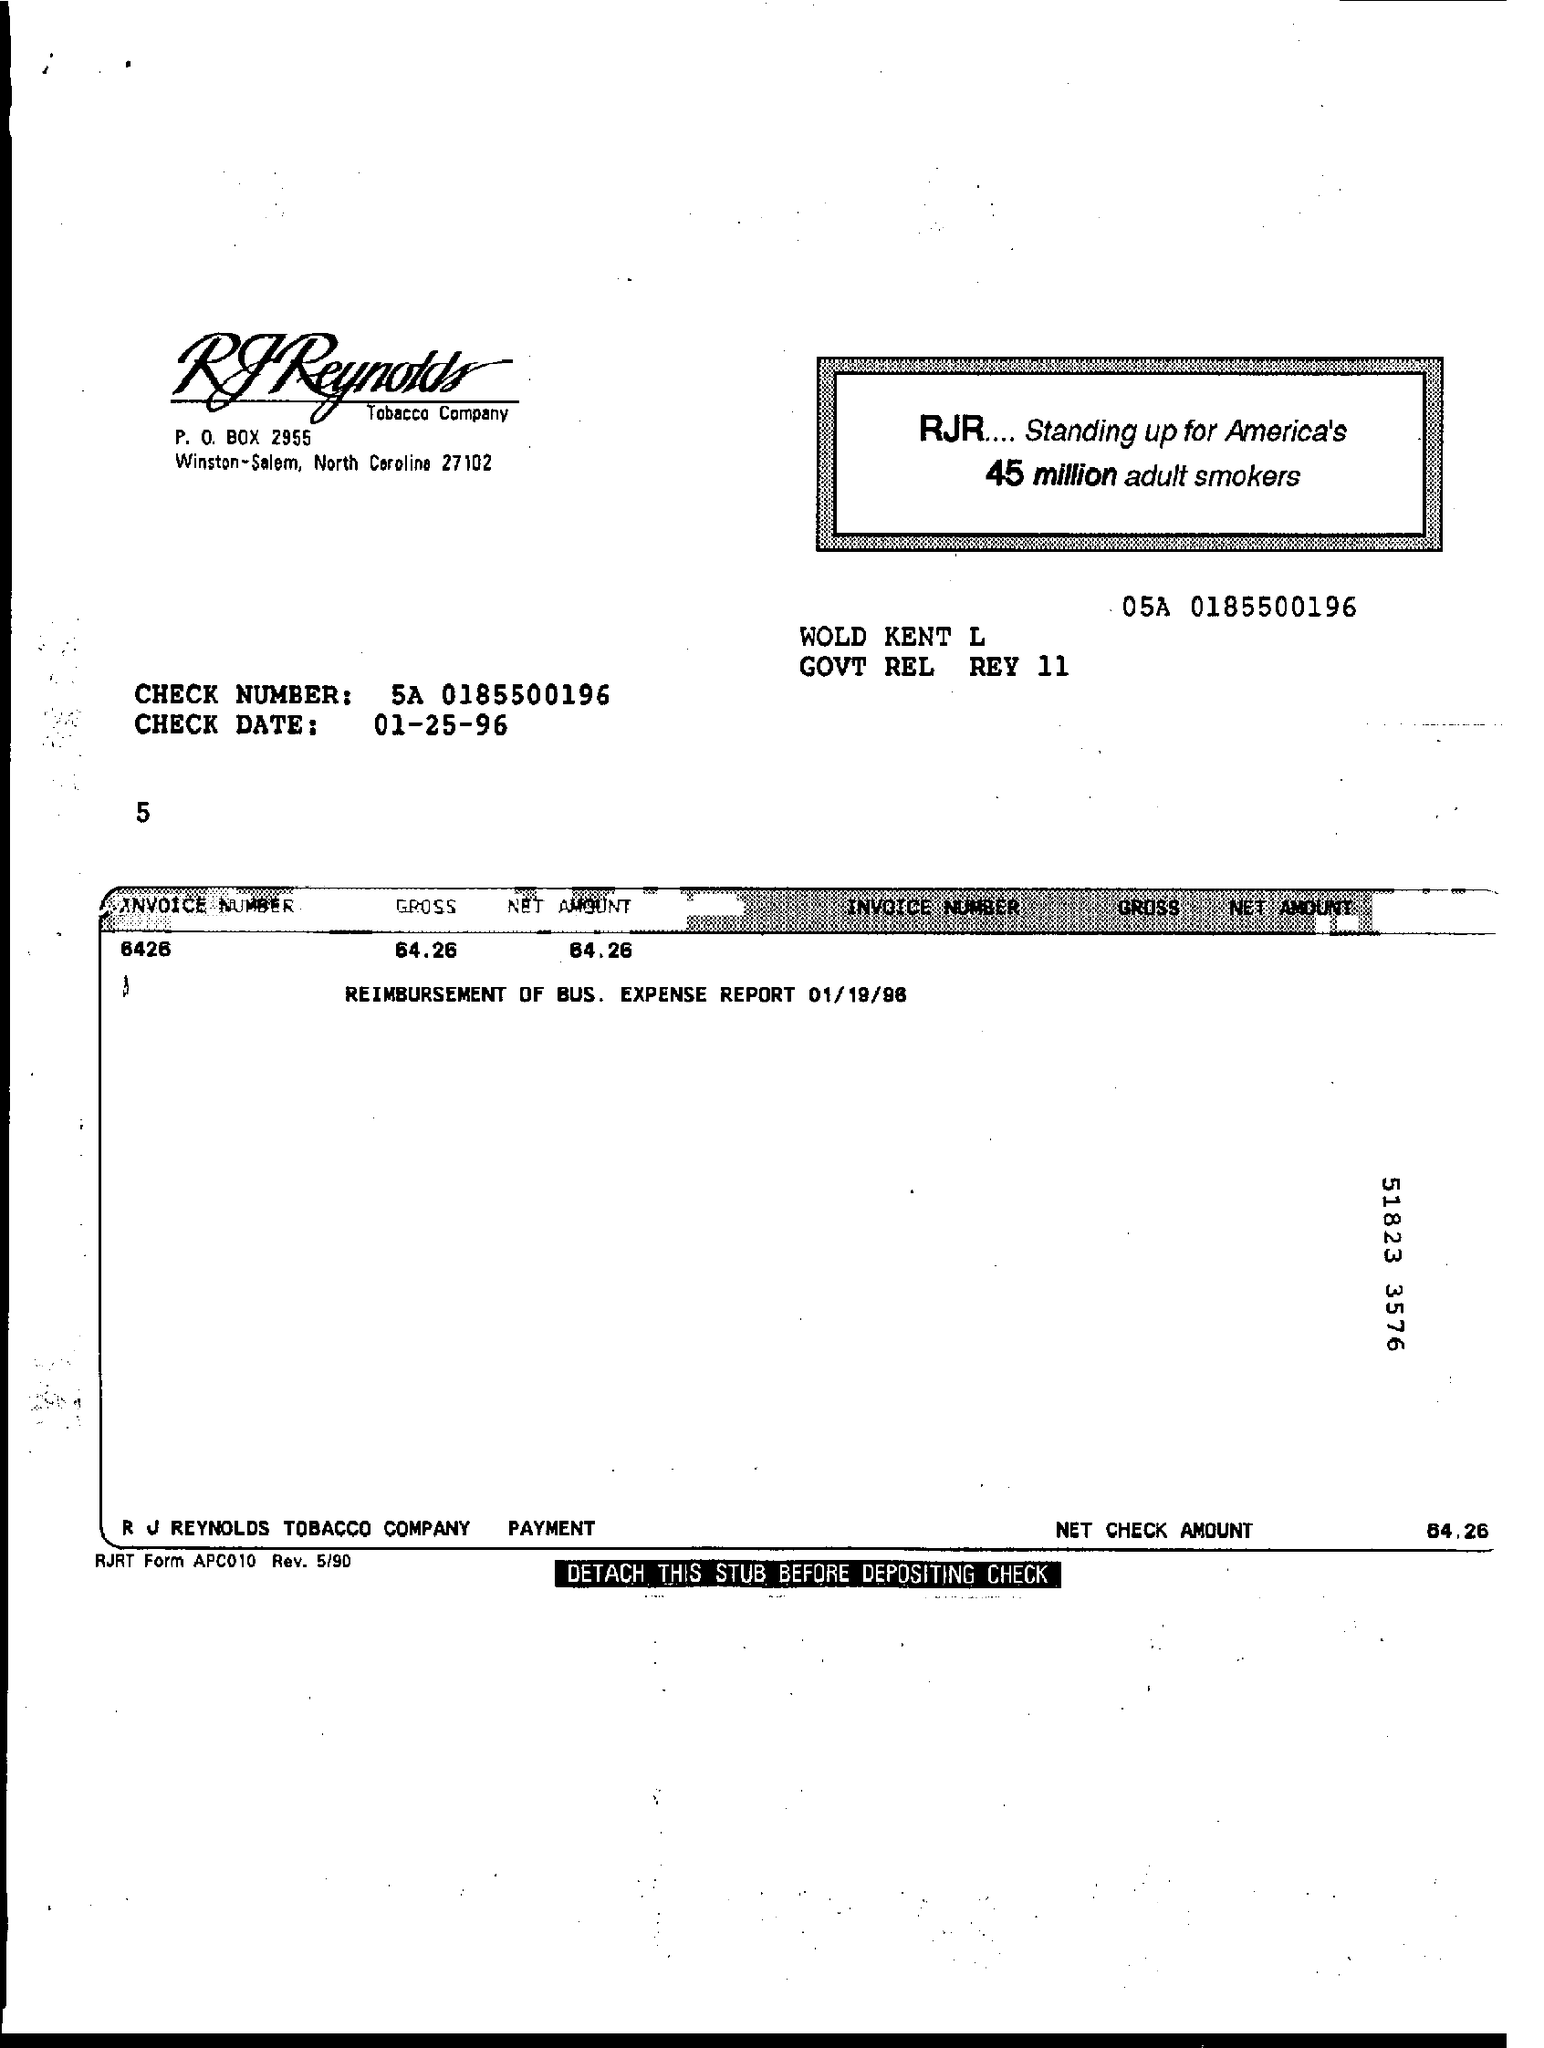Give some essential details in this illustration. Please provide the invoice number: 6426... The net amount is 64.26. On January 25, 1996, the date in question, is the check date. The net check amount is 64.26 dollars. The value is 64.26... 